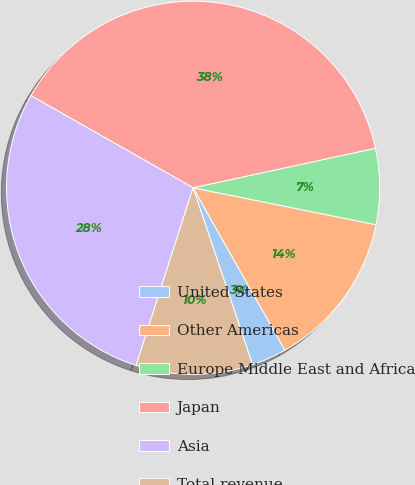Convert chart to OTSL. <chart><loc_0><loc_0><loc_500><loc_500><pie_chart><fcel>United States<fcel>Other Americas<fcel>Europe Middle East and Africa<fcel>Japan<fcel>Asia<fcel>Total revenue<nl><fcel>3.03%<fcel>13.64%<fcel>6.57%<fcel>38.38%<fcel>28.28%<fcel>10.1%<nl></chart> 